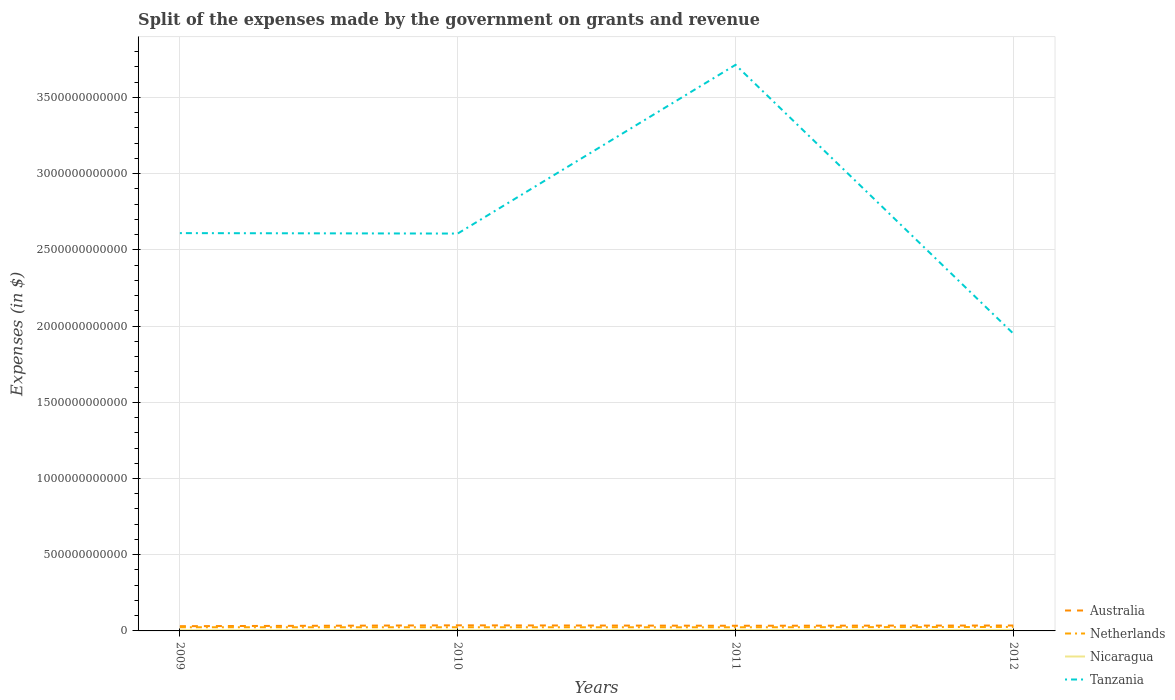Does the line corresponding to Australia intersect with the line corresponding to Tanzania?
Your answer should be compact. No. Across all years, what is the maximum expenses made by the government on grants and revenue in Tanzania?
Your response must be concise. 1.95e+12. What is the total expenses made by the government on grants and revenue in Netherlands in the graph?
Provide a short and direct response. -1.97e+09. What is the difference between the highest and the second highest expenses made by the government on grants and revenue in Netherlands?
Your answer should be very brief. 2.17e+09. What is the difference between the highest and the lowest expenses made by the government on grants and revenue in Tanzania?
Your response must be concise. 1. How many lines are there?
Your answer should be compact. 4. What is the difference between two consecutive major ticks on the Y-axis?
Your answer should be very brief. 5.00e+11. Does the graph contain any zero values?
Ensure brevity in your answer.  No. Does the graph contain grids?
Offer a very short reply. Yes. How many legend labels are there?
Your response must be concise. 4. What is the title of the graph?
Your answer should be very brief. Split of the expenses made by the government on grants and revenue. What is the label or title of the X-axis?
Ensure brevity in your answer.  Years. What is the label or title of the Y-axis?
Provide a short and direct response. Expenses (in $). What is the Expenses (in $) of Australia in 2009?
Your response must be concise. 3.10e+1. What is the Expenses (in $) in Netherlands in 2009?
Keep it short and to the point. 2.41e+1. What is the Expenses (in $) in Nicaragua in 2009?
Offer a very short reply. 4.76e+09. What is the Expenses (in $) in Tanzania in 2009?
Offer a terse response. 2.61e+12. What is the Expenses (in $) of Australia in 2010?
Make the answer very short. 3.67e+1. What is the Expenses (in $) in Netherlands in 2010?
Give a very brief answer. 2.41e+1. What is the Expenses (in $) of Nicaragua in 2010?
Your answer should be compact. 4.82e+09. What is the Expenses (in $) in Tanzania in 2010?
Provide a succinct answer. 2.61e+12. What is the Expenses (in $) in Australia in 2011?
Your answer should be compact. 3.39e+1. What is the Expenses (in $) of Netherlands in 2011?
Your answer should be very brief. 2.39e+1. What is the Expenses (in $) in Nicaragua in 2011?
Provide a succinct answer. 5.87e+09. What is the Expenses (in $) in Tanzania in 2011?
Offer a very short reply. 3.71e+12. What is the Expenses (in $) in Australia in 2012?
Your answer should be very brief. 3.55e+1. What is the Expenses (in $) in Netherlands in 2012?
Your answer should be very brief. 2.60e+1. What is the Expenses (in $) of Nicaragua in 2012?
Your response must be concise. 6.53e+09. What is the Expenses (in $) in Tanzania in 2012?
Provide a succinct answer. 1.95e+12. Across all years, what is the maximum Expenses (in $) of Australia?
Provide a succinct answer. 3.67e+1. Across all years, what is the maximum Expenses (in $) in Netherlands?
Provide a short and direct response. 2.60e+1. Across all years, what is the maximum Expenses (in $) in Nicaragua?
Provide a short and direct response. 6.53e+09. Across all years, what is the maximum Expenses (in $) in Tanzania?
Your answer should be very brief. 3.71e+12. Across all years, what is the minimum Expenses (in $) of Australia?
Keep it short and to the point. 3.10e+1. Across all years, what is the minimum Expenses (in $) in Netherlands?
Offer a terse response. 2.39e+1. Across all years, what is the minimum Expenses (in $) of Nicaragua?
Keep it short and to the point. 4.76e+09. Across all years, what is the minimum Expenses (in $) of Tanzania?
Provide a short and direct response. 1.95e+12. What is the total Expenses (in $) of Australia in the graph?
Provide a succinct answer. 1.37e+11. What is the total Expenses (in $) in Netherlands in the graph?
Offer a very short reply. 9.81e+1. What is the total Expenses (in $) of Nicaragua in the graph?
Your response must be concise. 2.20e+1. What is the total Expenses (in $) of Tanzania in the graph?
Ensure brevity in your answer.  1.09e+13. What is the difference between the Expenses (in $) of Australia in 2009 and that in 2010?
Your answer should be very brief. -5.63e+09. What is the difference between the Expenses (in $) in Netherlands in 2009 and that in 2010?
Provide a succinct answer. -7.90e+07. What is the difference between the Expenses (in $) in Nicaragua in 2009 and that in 2010?
Offer a very short reply. -5.97e+07. What is the difference between the Expenses (in $) of Tanzania in 2009 and that in 2010?
Give a very brief answer. 2.83e+09. What is the difference between the Expenses (in $) in Australia in 2009 and that in 2011?
Make the answer very short. -2.88e+09. What is the difference between the Expenses (in $) of Netherlands in 2009 and that in 2011?
Ensure brevity in your answer.  1.94e+08. What is the difference between the Expenses (in $) of Nicaragua in 2009 and that in 2011?
Provide a short and direct response. -1.11e+09. What is the difference between the Expenses (in $) in Tanzania in 2009 and that in 2011?
Keep it short and to the point. -1.10e+12. What is the difference between the Expenses (in $) of Australia in 2009 and that in 2012?
Give a very brief answer. -4.45e+09. What is the difference between the Expenses (in $) in Netherlands in 2009 and that in 2012?
Keep it short and to the point. -1.97e+09. What is the difference between the Expenses (in $) of Nicaragua in 2009 and that in 2012?
Offer a very short reply. -1.76e+09. What is the difference between the Expenses (in $) of Tanzania in 2009 and that in 2012?
Offer a very short reply. 6.60e+11. What is the difference between the Expenses (in $) in Australia in 2010 and that in 2011?
Make the answer very short. 2.75e+09. What is the difference between the Expenses (in $) in Netherlands in 2010 and that in 2011?
Make the answer very short. 2.73e+08. What is the difference between the Expenses (in $) of Nicaragua in 2010 and that in 2011?
Your answer should be very brief. -1.05e+09. What is the difference between the Expenses (in $) in Tanzania in 2010 and that in 2011?
Offer a terse response. -1.11e+12. What is the difference between the Expenses (in $) of Australia in 2010 and that in 2012?
Give a very brief answer. 1.18e+09. What is the difference between the Expenses (in $) of Netherlands in 2010 and that in 2012?
Provide a short and direct response. -1.89e+09. What is the difference between the Expenses (in $) of Nicaragua in 2010 and that in 2012?
Offer a very short reply. -1.70e+09. What is the difference between the Expenses (in $) of Tanzania in 2010 and that in 2012?
Keep it short and to the point. 6.57e+11. What is the difference between the Expenses (in $) in Australia in 2011 and that in 2012?
Offer a terse response. -1.57e+09. What is the difference between the Expenses (in $) in Netherlands in 2011 and that in 2012?
Give a very brief answer. -2.17e+09. What is the difference between the Expenses (in $) in Nicaragua in 2011 and that in 2012?
Offer a very short reply. -6.55e+08. What is the difference between the Expenses (in $) in Tanzania in 2011 and that in 2012?
Provide a succinct answer. 1.76e+12. What is the difference between the Expenses (in $) in Australia in 2009 and the Expenses (in $) in Netherlands in 2010?
Give a very brief answer. 6.89e+09. What is the difference between the Expenses (in $) in Australia in 2009 and the Expenses (in $) in Nicaragua in 2010?
Your answer should be very brief. 2.62e+1. What is the difference between the Expenses (in $) in Australia in 2009 and the Expenses (in $) in Tanzania in 2010?
Offer a very short reply. -2.58e+12. What is the difference between the Expenses (in $) in Netherlands in 2009 and the Expenses (in $) in Nicaragua in 2010?
Make the answer very short. 1.92e+1. What is the difference between the Expenses (in $) of Netherlands in 2009 and the Expenses (in $) of Tanzania in 2010?
Provide a short and direct response. -2.58e+12. What is the difference between the Expenses (in $) of Nicaragua in 2009 and the Expenses (in $) of Tanzania in 2010?
Provide a succinct answer. -2.60e+12. What is the difference between the Expenses (in $) in Australia in 2009 and the Expenses (in $) in Netherlands in 2011?
Keep it short and to the point. 7.16e+09. What is the difference between the Expenses (in $) of Australia in 2009 and the Expenses (in $) of Nicaragua in 2011?
Offer a very short reply. 2.51e+1. What is the difference between the Expenses (in $) in Australia in 2009 and the Expenses (in $) in Tanzania in 2011?
Keep it short and to the point. -3.68e+12. What is the difference between the Expenses (in $) of Netherlands in 2009 and the Expenses (in $) of Nicaragua in 2011?
Ensure brevity in your answer.  1.82e+1. What is the difference between the Expenses (in $) of Netherlands in 2009 and the Expenses (in $) of Tanzania in 2011?
Make the answer very short. -3.69e+12. What is the difference between the Expenses (in $) in Nicaragua in 2009 and the Expenses (in $) in Tanzania in 2011?
Your answer should be compact. -3.71e+12. What is the difference between the Expenses (in $) of Australia in 2009 and the Expenses (in $) of Netherlands in 2012?
Provide a succinct answer. 5.00e+09. What is the difference between the Expenses (in $) in Australia in 2009 and the Expenses (in $) in Nicaragua in 2012?
Provide a succinct answer. 2.45e+1. What is the difference between the Expenses (in $) of Australia in 2009 and the Expenses (in $) of Tanzania in 2012?
Keep it short and to the point. -1.92e+12. What is the difference between the Expenses (in $) in Netherlands in 2009 and the Expenses (in $) in Nicaragua in 2012?
Keep it short and to the point. 1.75e+1. What is the difference between the Expenses (in $) in Netherlands in 2009 and the Expenses (in $) in Tanzania in 2012?
Your response must be concise. -1.93e+12. What is the difference between the Expenses (in $) in Nicaragua in 2009 and the Expenses (in $) in Tanzania in 2012?
Offer a terse response. -1.95e+12. What is the difference between the Expenses (in $) of Australia in 2010 and the Expenses (in $) of Netherlands in 2011?
Make the answer very short. 1.28e+1. What is the difference between the Expenses (in $) in Australia in 2010 and the Expenses (in $) in Nicaragua in 2011?
Provide a short and direct response. 3.08e+1. What is the difference between the Expenses (in $) of Australia in 2010 and the Expenses (in $) of Tanzania in 2011?
Make the answer very short. -3.68e+12. What is the difference between the Expenses (in $) in Netherlands in 2010 and the Expenses (in $) in Nicaragua in 2011?
Make the answer very short. 1.83e+1. What is the difference between the Expenses (in $) of Netherlands in 2010 and the Expenses (in $) of Tanzania in 2011?
Make the answer very short. -3.69e+12. What is the difference between the Expenses (in $) in Nicaragua in 2010 and the Expenses (in $) in Tanzania in 2011?
Your answer should be compact. -3.71e+12. What is the difference between the Expenses (in $) in Australia in 2010 and the Expenses (in $) in Netherlands in 2012?
Your response must be concise. 1.06e+1. What is the difference between the Expenses (in $) in Australia in 2010 and the Expenses (in $) in Nicaragua in 2012?
Keep it short and to the point. 3.01e+1. What is the difference between the Expenses (in $) of Australia in 2010 and the Expenses (in $) of Tanzania in 2012?
Offer a very short reply. -1.91e+12. What is the difference between the Expenses (in $) of Netherlands in 2010 and the Expenses (in $) of Nicaragua in 2012?
Make the answer very short. 1.76e+1. What is the difference between the Expenses (in $) of Netherlands in 2010 and the Expenses (in $) of Tanzania in 2012?
Ensure brevity in your answer.  -1.93e+12. What is the difference between the Expenses (in $) in Nicaragua in 2010 and the Expenses (in $) in Tanzania in 2012?
Ensure brevity in your answer.  -1.95e+12. What is the difference between the Expenses (in $) in Australia in 2011 and the Expenses (in $) in Netherlands in 2012?
Your answer should be compact. 7.88e+09. What is the difference between the Expenses (in $) in Australia in 2011 and the Expenses (in $) in Nicaragua in 2012?
Give a very brief answer. 2.74e+1. What is the difference between the Expenses (in $) in Australia in 2011 and the Expenses (in $) in Tanzania in 2012?
Make the answer very short. -1.92e+12. What is the difference between the Expenses (in $) of Netherlands in 2011 and the Expenses (in $) of Nicaragua in 2012?
Your answer should be compact. 1.73e+1. What is the difference between the Expenses (in $) in Netherlands in 2011 and the Expenses (in $) in Tanzania in 2012?
Offer a terse response. -1.93e+12. What is the difference between the Expenses (in $) in Nicaragua in 2011 and the Expenses (in $) in Tanzania in 2012?
Provide a succinct answer. -1.94e+12. What is the average Expenses (in $) of Australia per year?
Ensure brevity in your answer.  3.43e+1. What is the average Expenses (in $) in Netherlands per year?
Your answer should be compact. 2.45e+1. What is the average Expenses (in $) of Nicaragua per year?
Your answer should be very brief. 5.50e+09. What is the average Expenses (in $) in Tanzania per year?
Offer a very short reply. 2.72e+12. In the year 2009, what is the difference between the Expenses (in $) of Australia and Expenses (in $) of Netherlands?
Your response must be concise. 6.97e+09. In the year 2009, what is the difference between the Expenses (in $) in Australia and Expenses (in $) in Nicaragua?
Provide a succinct answer. 2.63e+1. In the year 2009, what is the difference between the Expenses (in $) in Australia and Expenses (in $) in Tanzania?
Keep it short and to the point. -2.58e+12. In the year 2009, what is the difference between the Expenses (in $) of Netherlands and Expenses (in $) of Nicaragua?
Offer a terse response. 1.93e+1. In the year 2009, what is the difference between the Expenses (in $) of Netherlands and Expenses (in $) of Tanzania?
Ensure brevity in your answer.  -2.59e+12. In the year 2009, what is the difference between the Expenses (in $) in Nicaragua and Expenses (in $) in Tanzania?
Offer a very short reply. -2.60e+12. In the year 2010, what is the difference between the Expenses (in $) of Australia and Expenses (in $) of Netherlands?
Keep it short and to the point. 1.25e+1. In the year 2010, what is the difference between the Expenses (in $) of Australia and Expenses (in $) of Nicaragua?
Offer a very short reply. 3.18e+1. In the year 2010, what is the difference between the Expenses (in $) in Australia and Expenses (in $) in Tanzania?
Your answer should be compact. -2.57e+12. In the year 2010, what is the difference between the Expenses (in $) in Netherlands and Expenses (in $) in Nicaragua?
Provide a succinct answer. 1.93e+1. In the year 2010, what is the difference between the Expenses (in $) of Netherlands and Expenses (in $) of Tanzania?
Offer a very short reply. -2.58e+12. In the year 2010, what is the difference between the Expenses (in $) in Nicaragua and Expenses (in $) in Tanzania?
Your answer should be very brief. -2.60e+12. In the year 2011, what is the difference between the Expenses (in $) of Australia and Expenses (in $) of Netherlands?
Keep it short and to the point. 1.00e+1. In the year 2011, what is the difference between the Expenses (in $) in Australia and Expenses (in $) in Nicaragua?
Give a very brief answer. 2.80e+1. In the year 2011, what is the difference between the Expenses (in $) in Australia and Expenses (in $) in Tanzania?
Provide a succinct answer. -3.68e+12. In the year 2011, what is the difference between the Expenses (in $) in Netherlands and Expenses (in $) in Nicaragua?
Your response must be concise. 1.80e+1. In the year 2011, what is the difference between the Expenses (in $) of Netherlands and Expenses (in $) of Tanzania?
Offer a very short reply. -3.69e+12. In the year 2011, what is the difference between the Expenses (in $) in Nicaragua and Expenses (in $) in Tanzania?
Your response must be concise. -3.71e+12. In the year 2012, what is the difference between the Expenses (in $) in Australia and Expenses (in $) in Netherlands?
Offer a very short reply. 9.45e+09. In the year 2012, what is the difference between the Expenses (in $) in Australia and Expenses (in $) in Nicaragua?
Ensure brevity in your answer.  2.89e+1. In the year 2012, what is the difference between the Expenses (in $) of Australia and Expenses (in $) of Tanzania?
Provide a short and direct response. -1.91e+12. In the year 2012, what is the difference between the Expenses (in $) of Netherlands and Expenses (in $) of Nicaragua?
Your answer should be compact. 1.95e+1. In the year 2012, what is the difference between the Expenses (in $) of Netherlands and Expenses (in $) of Tanzania?
Your answer should be very brief. -1.92e+12. In the year 2012, what is the difference between the Expenses (in $) of Nicaragua and Expenses (in $) of Tanzania?
Give a very brief answer. -1.94e+12. What is the ratio of the Expenses (in $) in Australia in 2009 to that in 2010?
Make the answer very short. 0.85. What is the ratio of the Expenses (in $) of Nicaragua in 2009 to that in 2010?
Ensure brevity in your answer.  0.99. What is the ratio of the Expenses (in $) of Australia in 2009 to that in 2011?
Provide a succinct answer. 0.92. What is the ratio of the Expenses (in $) in Netherlands in 2009 to that in 2011?
Your answer should be very brief. 1.01. What is the ratio of the Expenses (in $) of Nicaragua in 2009 to that in 2011?
Provide a succinct answer. 0.81. What is the ratio of the Expenses (in $) in Tanzania in 2009 to that in 2011?
Ensure brevity in your answer.  0.7. What is the ratio of the Expenses (in $) in Australia in 2009 to that in 2012?
Offer a terse response. 0.87. What is the ratio of the Expenses (in $) of Netherlands in 2009 to that in 2012?
Provide a short and direct response. 0.92. What is the ratio of the Expenses (in $) of Nicaragua in 2009 to that in 2012?
Provide a short and direct response. 0.73. What is the ratio of the Expenses (in $) in Tanzania in 2009 to that in 2012?
Provide a short and direct response. 1.34. What is the ratio of the Expenses (in $) of Australia in 2010 to that in 2011?
Offer a terse response. 1.08. What is the ratio of the Expenses (in $) in Netherlands in 2010 to that in 2011?
Keep it short and to the point. 1.01. What is the ratio of the Expenses (in $) of Nicaragua in 2010 to that in 2011?
Give a very brief answer. 0.82. What is the ratio of the Expenses (in $) in Tanzania in 2010 to that in 2011?
Keep it short and to the point. 0.7. What is the ratio of the Expenses (in $) in Netherlands in 2010 to that in 2012?
Your response must be concise. 0.93. What is the ratio of the Expenses (in $) of Nicaragua in 2010 to that in 2012?
Make the answer very short. 0.74. What is the ratio of the Expenses (in $) in Tanzania in 2010 to that in 2012?
Offer a terse response. 1.34. What is the ratio of the Expenses (in $) of Australia in 2011 to that in 2012?
Your answer should be very brief. 0.96. What is the ratio of the Expenses (in $) in Netherlands in 2011 to that in 2012?
Make the answer very short. 0.92. What is the ratio of the Expenses (in $) in Nicaragua in 2011 to that in 2012?
Make the answer very short. 0.9. What is the ratio of the Expenses (in $) in Tanzania in 2011 to that in 2012?
Ensure brevity in your answer.  1.9. What is the difference between the highest and the second highest Expenses (in $) in Australia?
Keep it short and to the point. 1.18e+09. What is the difference between the highest and the second highest Expenses (in $) in Netherlands?
Keep it short and to the point. 1.89e+09. What is the difference between the highest and the second highest Expenses (in $) in Nicaragua?
Give a very brief answer. 6.55e+08. What is the difference between the highest and the second highest Expenses (in $) of Tanzania?
Provide a succinct answer. 1.10e+12. What is the difference between the highest and the lowest Expenses (in $) of Australia?
Make the answer very short. 5.63e+09. What is the difference between the highest and the lowest Expenses (in $) in Netherlands?
Keep it short and to the point. 2.17e+09. What is the difference between the highest and the lowest Expenses (in $) of Nicaragua?
Ensure brevity in your answer.  1.76e+09. What is the difference between the highest and the lowest Expenses (in $) in Tanzania?
Your answer should be very brief. 1.76e+12. 